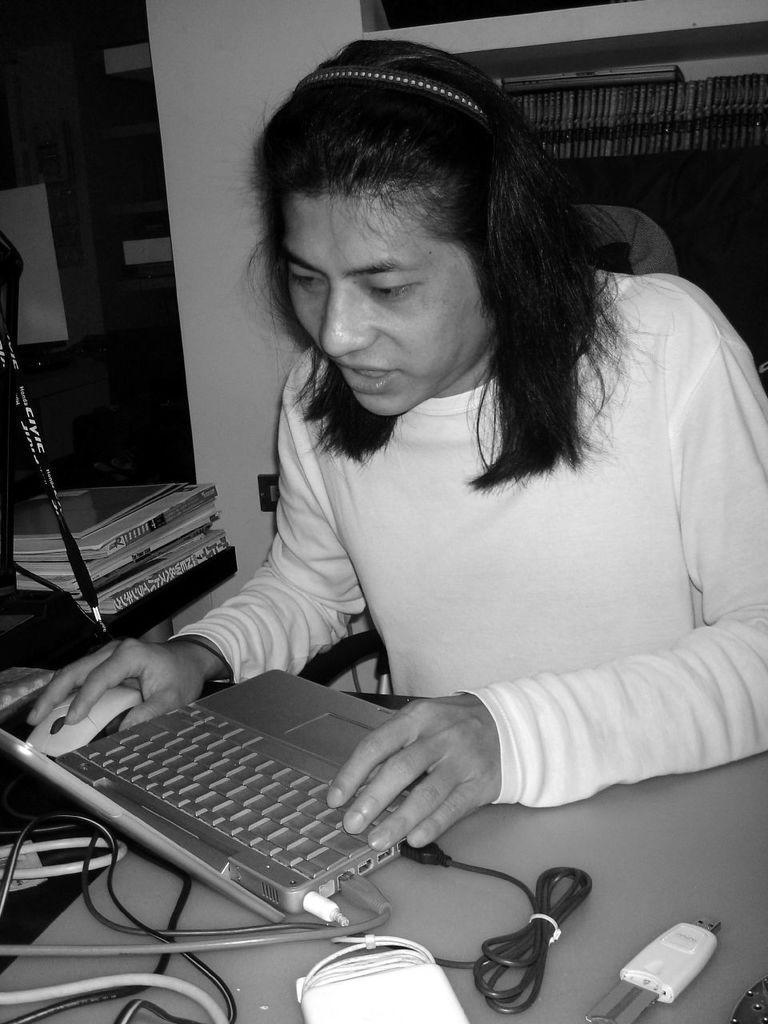Describe this image in one or two sentences. This woman is sitting on a chair and working on her laptop. On this table we can see cables, laptop and mouse. This rack it filled with books. Here we can see books. 